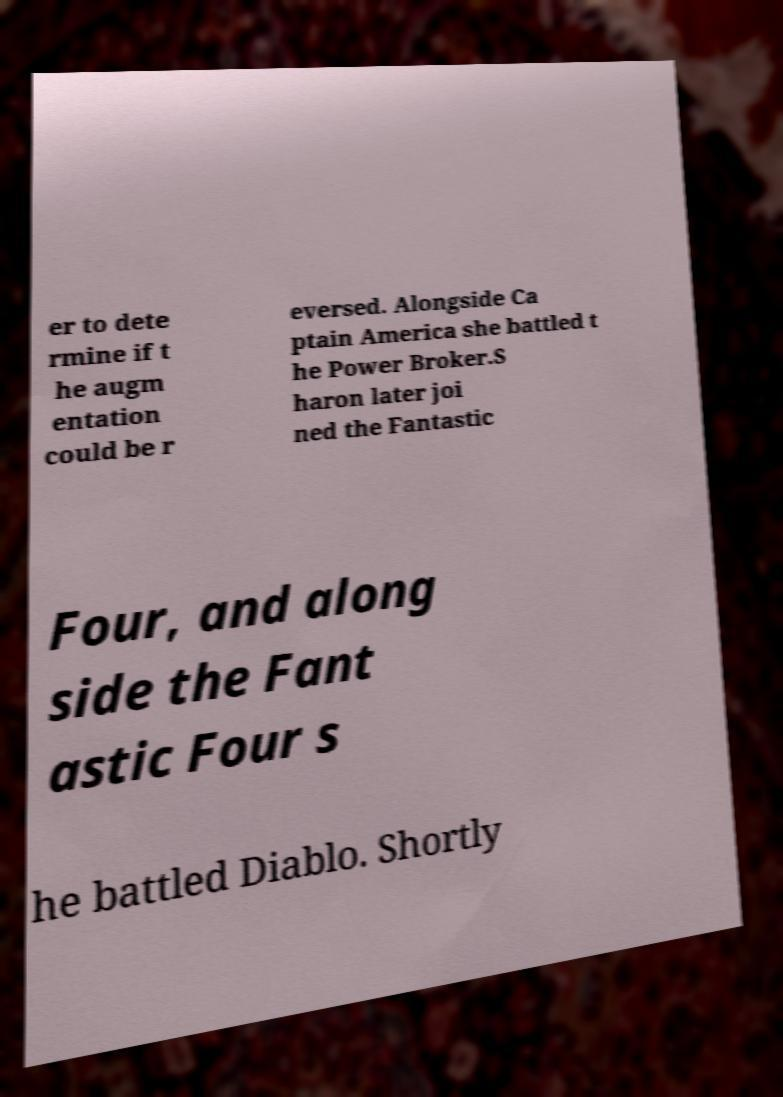There's text embedded in this image that I need extracted. Can you transcribe it verbatim? er to dete rmine if t he augm entation could be r eversed. Alongside Ca ptain America she battled t he Power Broker.S haron later joi ned the Fantastic Four, and along side the Fant astic Four s he battled Diablo. Shortly 